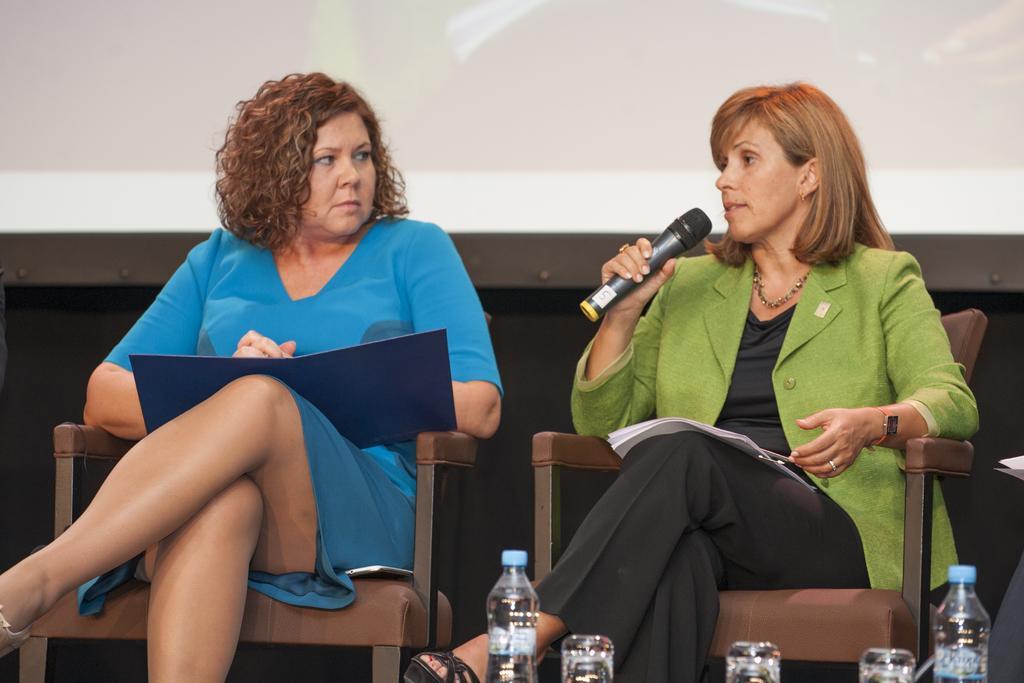Can you describe this image briefly? There is a woman with curly hair sat in chair with file her hand and woman beside her wearing a green suit talking on mic ,In front of them there are water bottles and behind them there is a screen. 